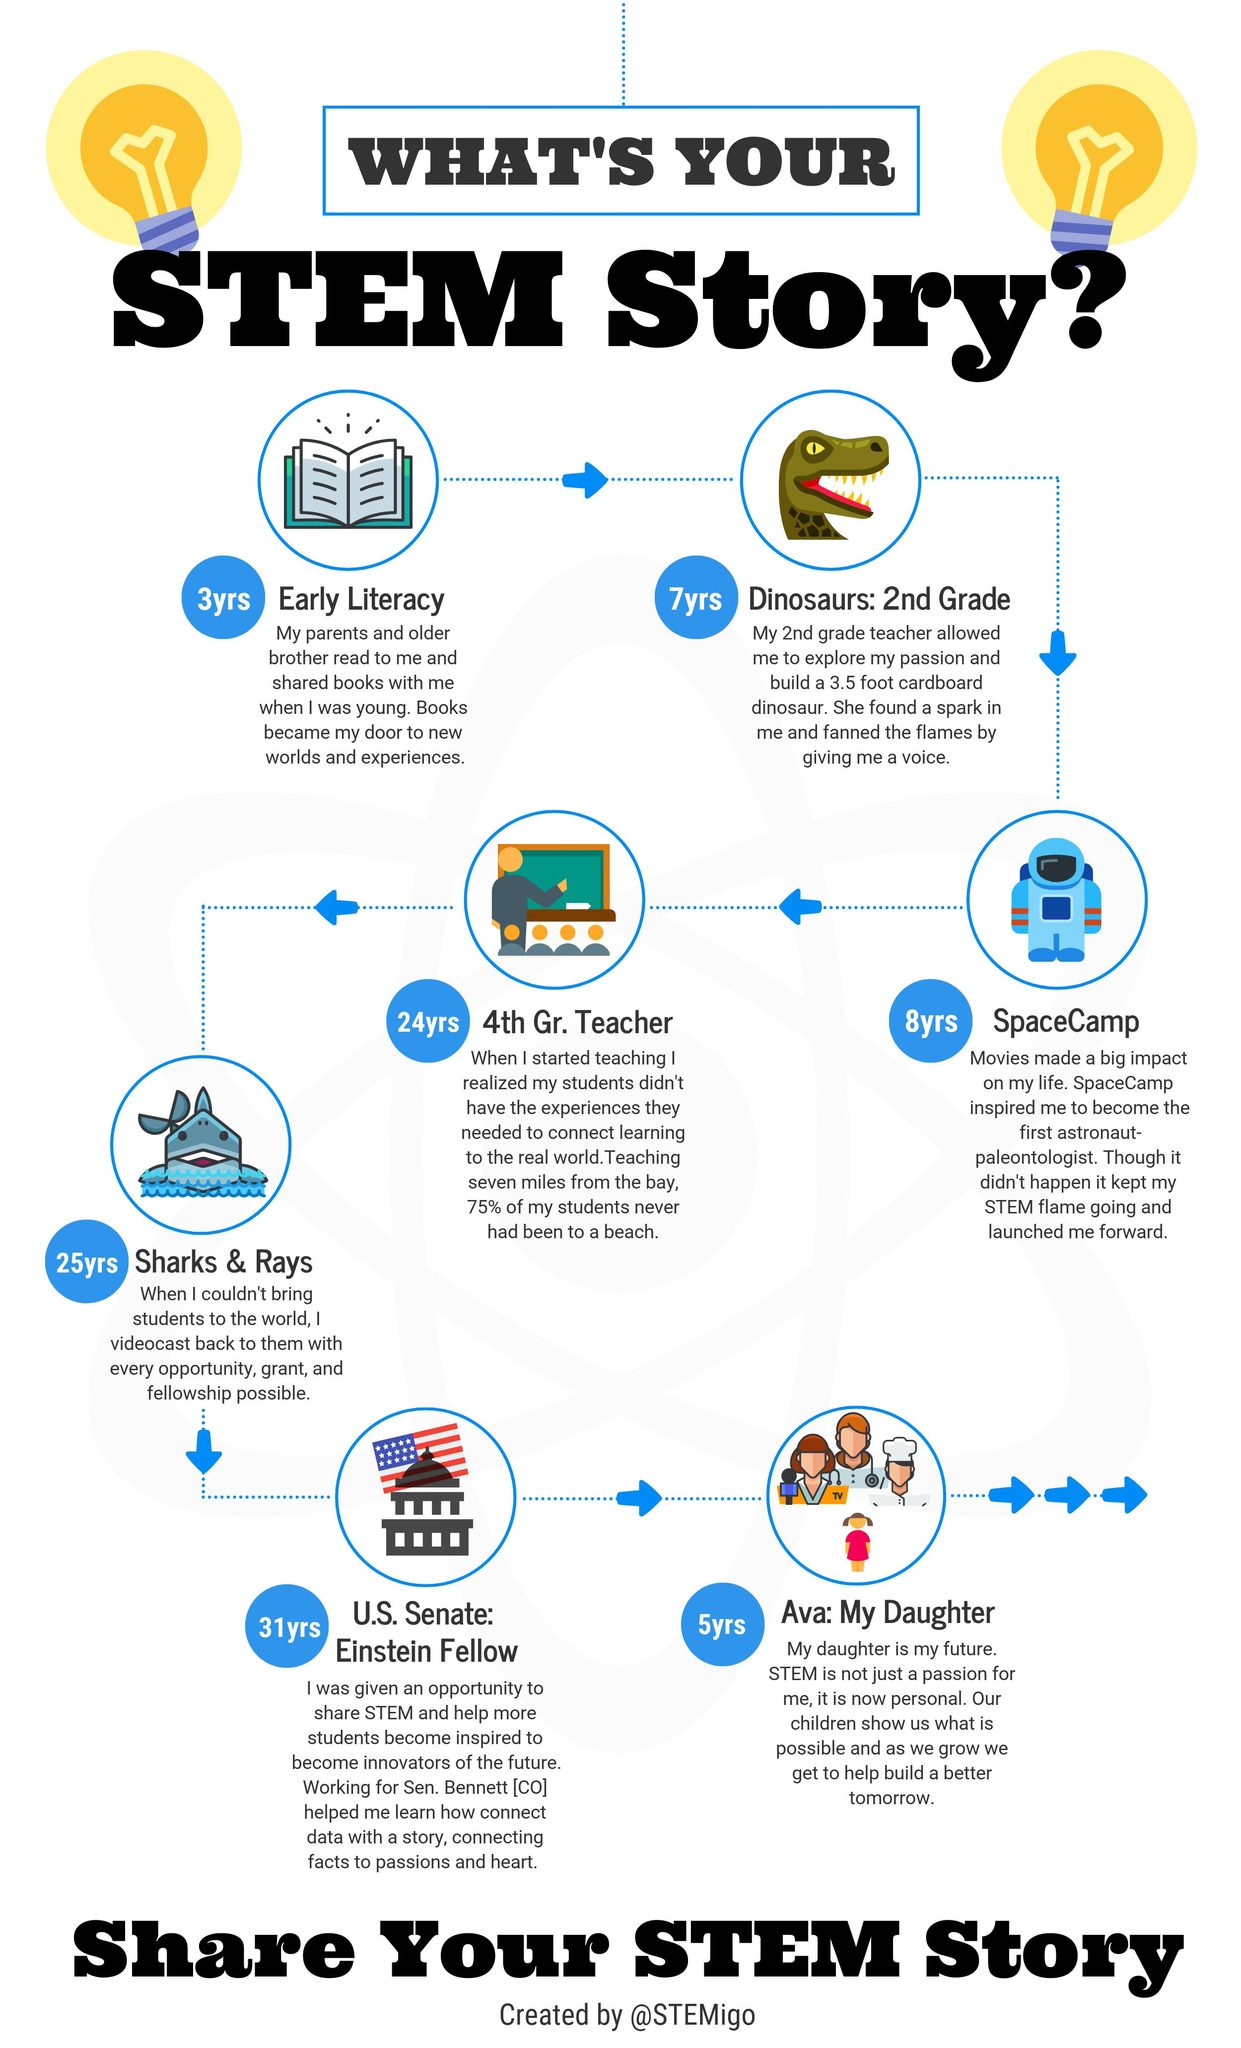Mention a couple of crucial points in this snapshot. The topic presented below the book icon is 'Early Literacy.' The text "stem story" in the heading is black. The topic of the STEM story of an 8-year-old child is spacecamp. This infographic contains one icon of a book. The topic of the STEM story of a 24-year-old 4th grade teacher is... 